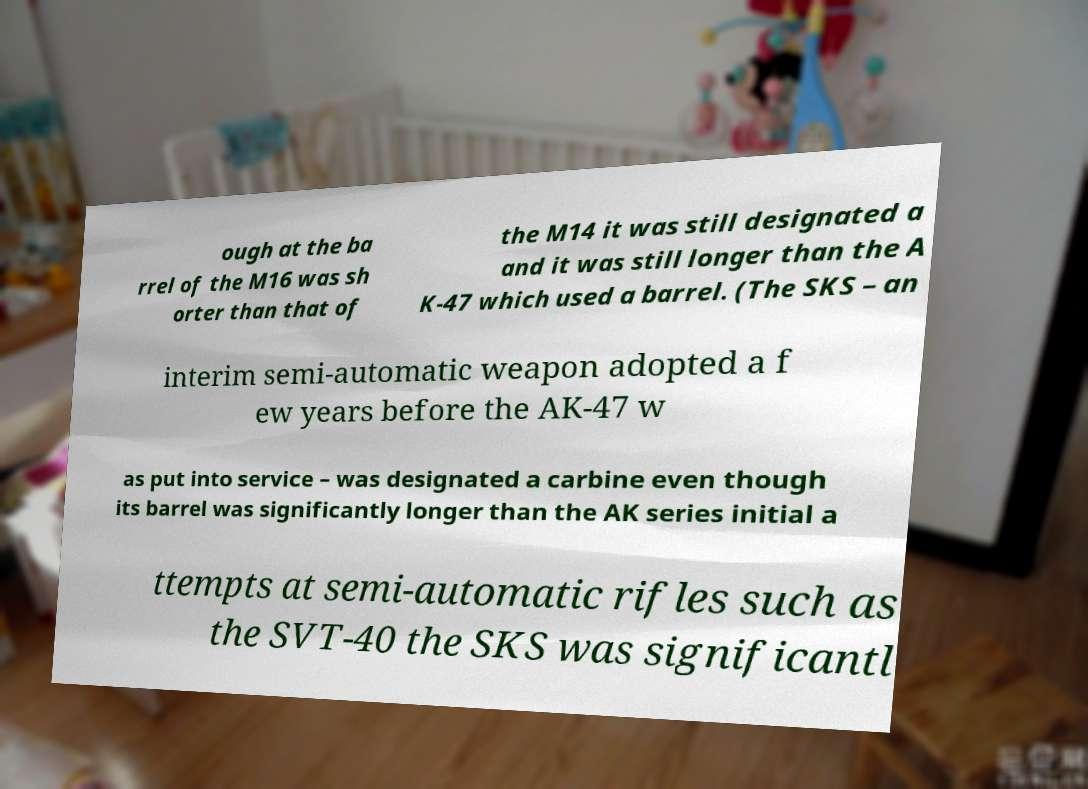There's text embedded in this image that I need extracted. Can you transcribe it verbatim? ough at the ba rrel of the M16 was sh orter than that of the M14 it was still designated a and it was still longer than the A K-47 which used a barrel. (The SKS – an interim semi-automatic weapon adopted a f ew years before the AK-47 w as put into service – was designated a carbine even though its barrel was significantly longer than the AK series initial a ttempts at semi-automatic rifles such as the SVT-40 the SKS was significantl 